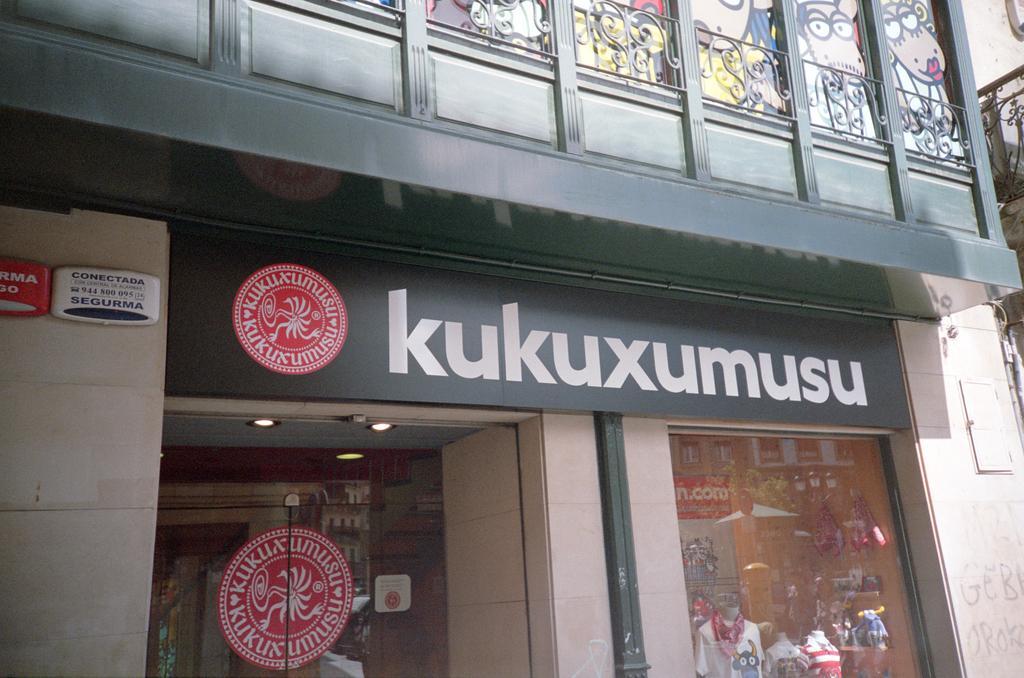Can you describe this image briefly? In this picture, we see a building in white and green color. At the bottom, we see the glass doors from which we can see the mannequins of the boy and the girl. We see a red color sticker is pasted on the glass door. On the left side, we see a wall on which the red and white color boards are placed. we see some text written on the boards. On the right side, we see a white board is placed on the wall. In the middle, we see a board in green color with some text written on it. At the top, we see the railing and the painting of the cartoons on the wall. 